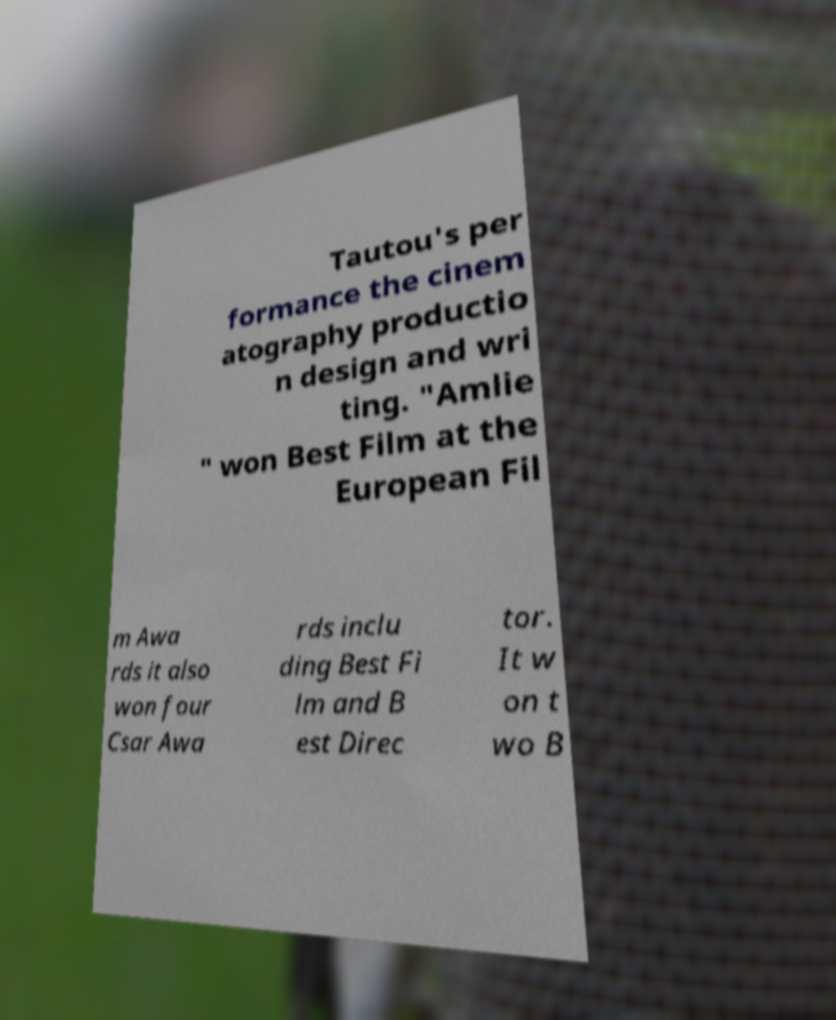Can you accurately transcribe the text from the provided image for me? Tautou's per formance the cinem atography productio n design and wri ting. "Amlie " won Best Film at the European Fil m Awa rds it also won four Csar Awa rds inclu ding Best Fi lm and B est Direc tor. It w on t wo B 